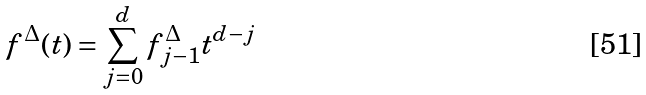<formula> <loc_0><loc_0><loc_500><loc_500>f ^ { \Delta } ( t ) = \sum _ { j = 0 } ^ { d } f _ { j - 1 } ^ { \Delta } t ^ { d - j }</formula> 